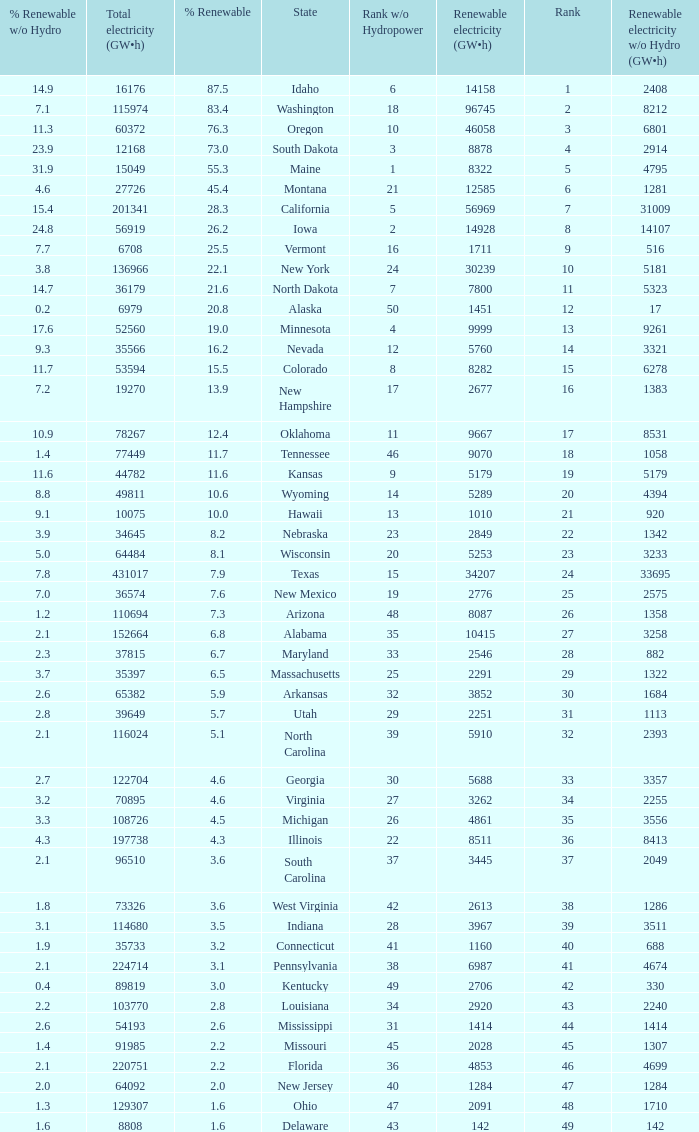What is the maximum renewable energy (gw×h) for the state of Delaware? 142.0. 